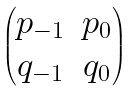Convert formula to latex. <formula><loc_0><loc_0><loc_500><loc_500>\begin{pmatrix} p _ { - 1 } & p _ { 0 } \\ q _ { - 1 } & q _ { 0 } \\ \end{pmatrix}</formula> 